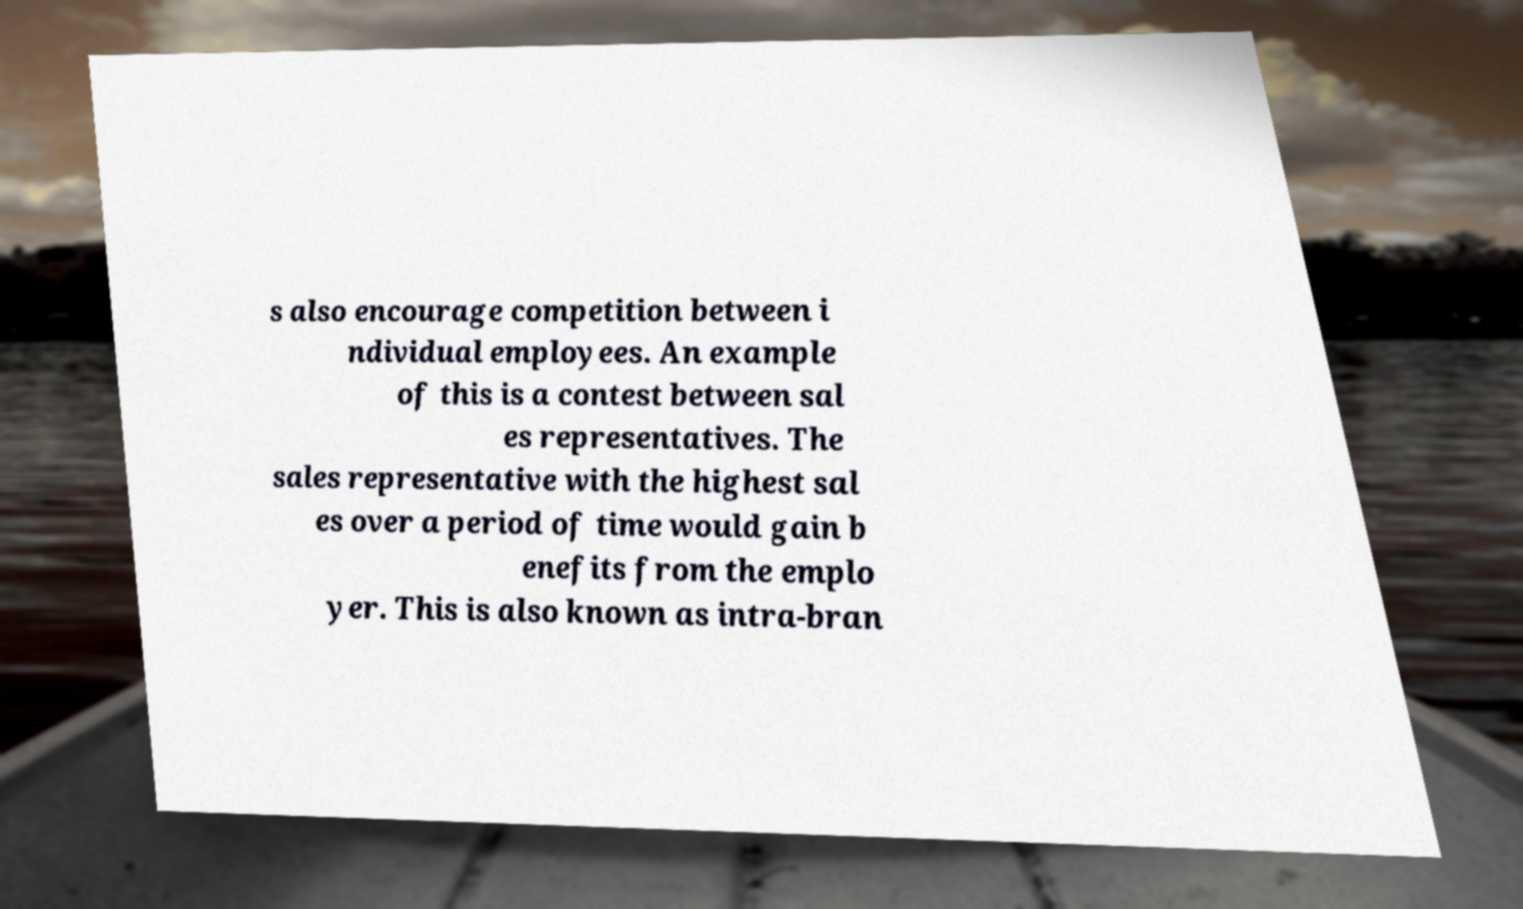For documentation purposes, I need the text within this image transcribed. Could you provide that? s also encourage competition between i ndividual employees. An example of this is a contest between sal es representatives. The sales representative with the highest sal es over a period of time would gain b enefits from the emplo yer. This is also known as intra-bran 